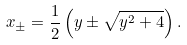Convert formula to latex. <formula><loc_0><loc_0><loc_500><loc_500>x _ { \pm } = \frac { 1 } { 2 } \left ( y \pm \sqrt { y ^ { 2 } + 4 } \right ) .</formula> 